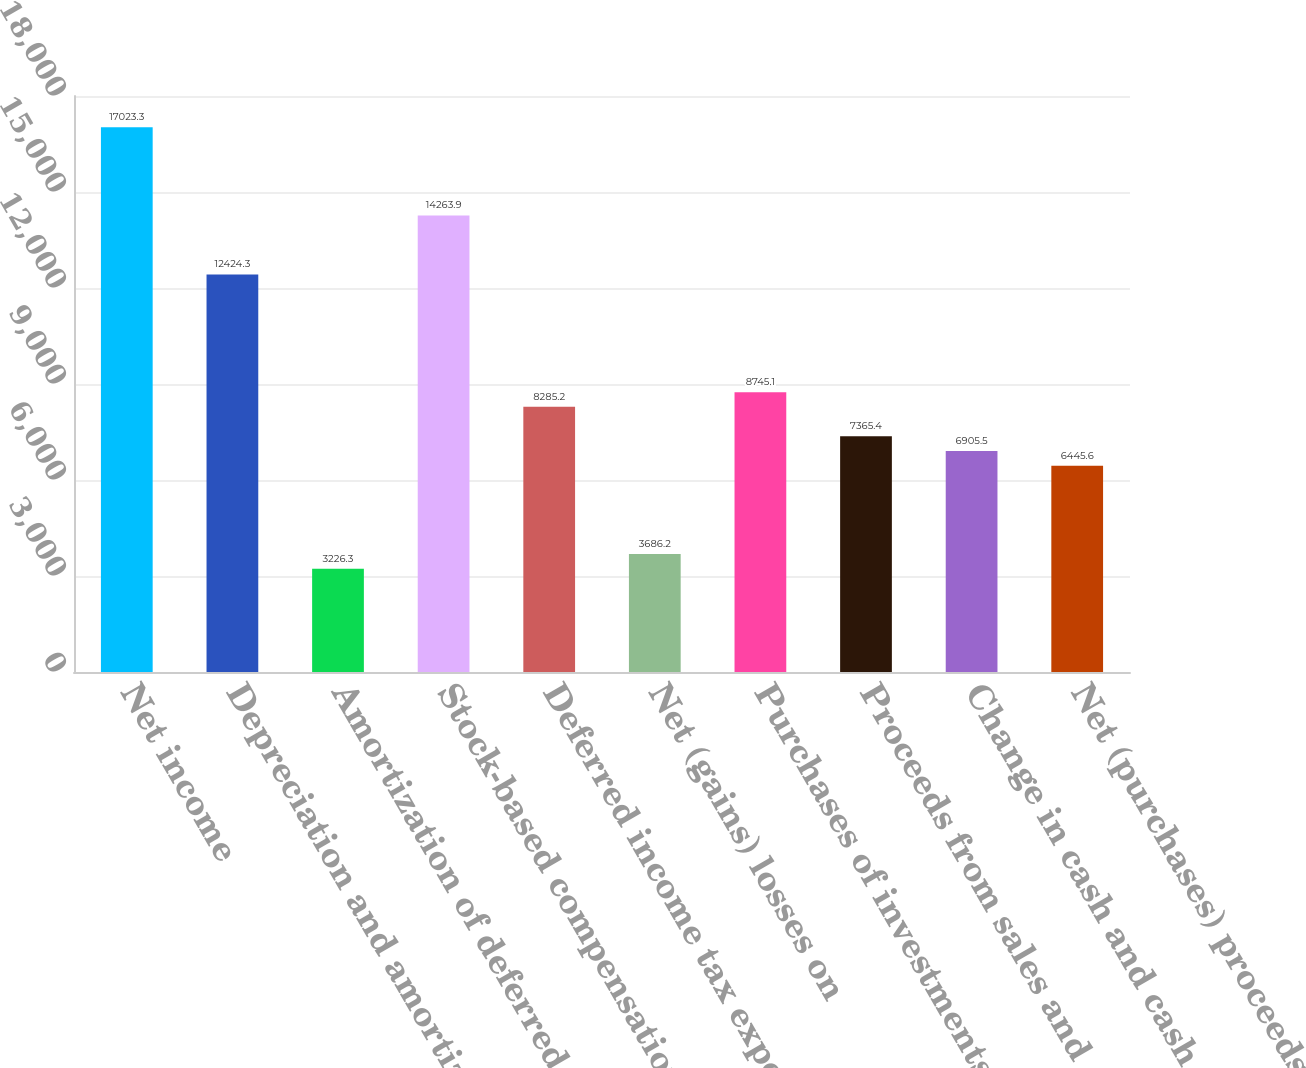Convert chart to OTSL. <chart><loc_0><loc_0><loc_500><loc_500><bar_chart><fcel>Net income<fcel>Depreciation and amortization<fcel>Amortization of deferred sales<fcel>Stock-based compensation<fcel>Deferred income tax expense<fcel>Net (gains) losses on<fcel>Purchases of investments<fcel>Proceeds from sales and<fcel>Change in cash and cash<fcel>Net (purchases) proceeds<nl><fcel>17023.3<fcel>12424.3<fcel>3226.3<fcel>14263.9<fcel>8285.2<fcel>3686.2<fcel>8745.1<fcel>7365.4<fcel>6905.5<fcel>6445.6<nl></chart> 